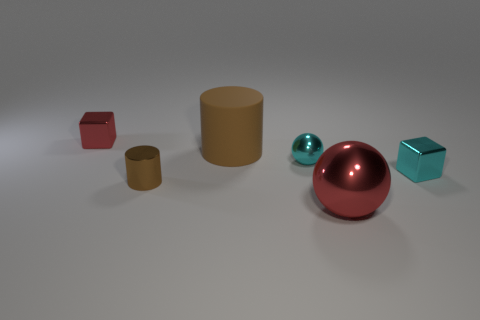Add 1 tiny cyan blocks. How many objects exist? 7 Subtract 1 blocks. How many blocks are left? 1 Add 6 small red metallic cubes. How many small red metallic cubes exist? 7 Subtract 0 purple balls. How many objects are left? 6 Subtract all brown blocks. Subtract all brown spheres. How many blocks are left? 2 Subtract all green cylinders. How many red cubes are left? 1 Subtract all big green objects. Subtract all brown metallic cylinders. How many objects are left? 5 Add 2 metallic cubes. How many metallic cubes are left? 4 